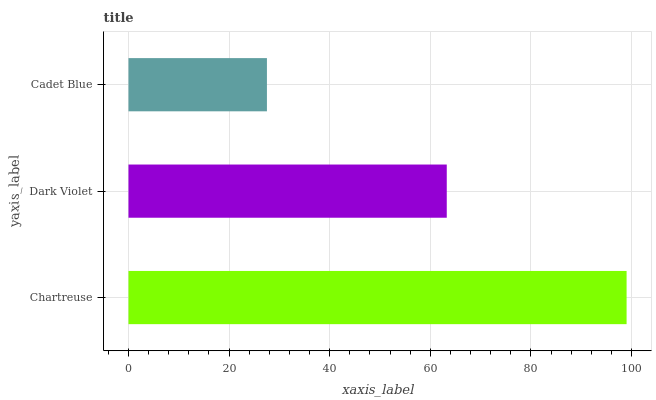Is Cadet Blue the minimum?
Answer yes or no. Yes. Is Chartreuse the maximum?
Answer yes or no. Yes. Is Dark Violet the minimum?
Answer yes or no. No. Is Dark Violet the maximum?
Answer yes or no. No. Is Chartreuse greater than Dark Violet?
Answer yes or no. Yes. Is Dark Violet less than Chartreuse?
Answer yes or no. Yes. Is Dark Violet greater than Chartreuse?
Answer yes or no. No. Is Chartreuse less than Dark Violet?
Answer yes or no. No. Is Dark Violet the high median?
Answer yes or no. Yes. Is Dark Violet the low median?
Answer yes or no. Yes. Is Chartreuse the high median?
Answer yes or no. No. Is Chartreuse the low median?
Answer yes or no. No. 